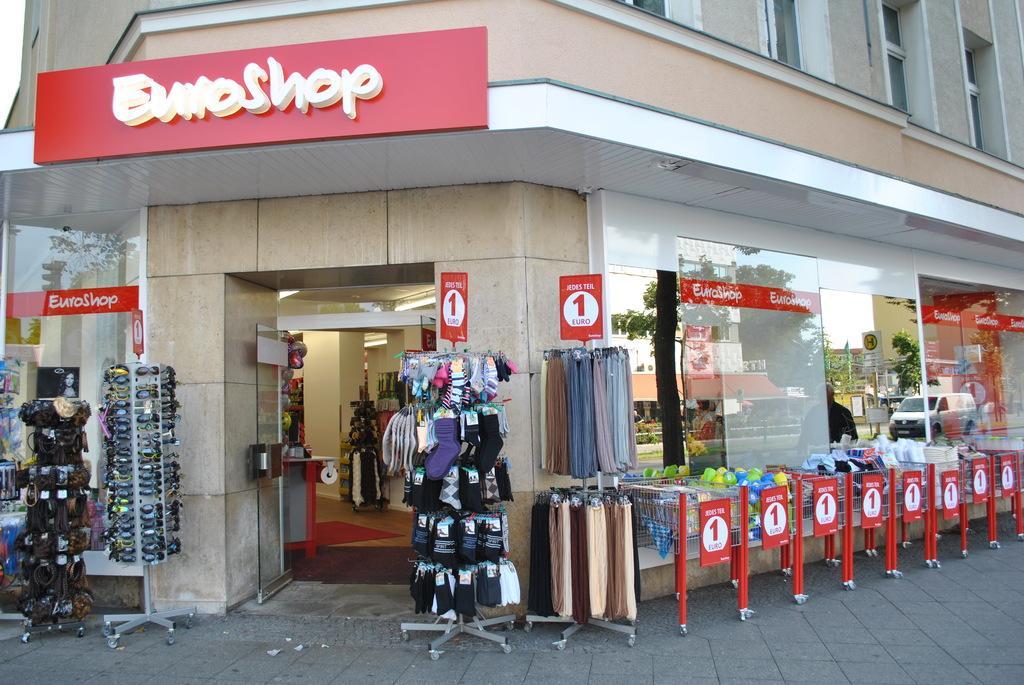Please provide a concise description of this image. In this picture I can see clothes, pairs of socks and some other items hanging to the hangers, there are spectacles arranged in an order, there are trolley baskets with some items in it , there are boards, a building, there is a table, mat , lights and some other items inside a building, there are vehicles, trees. 